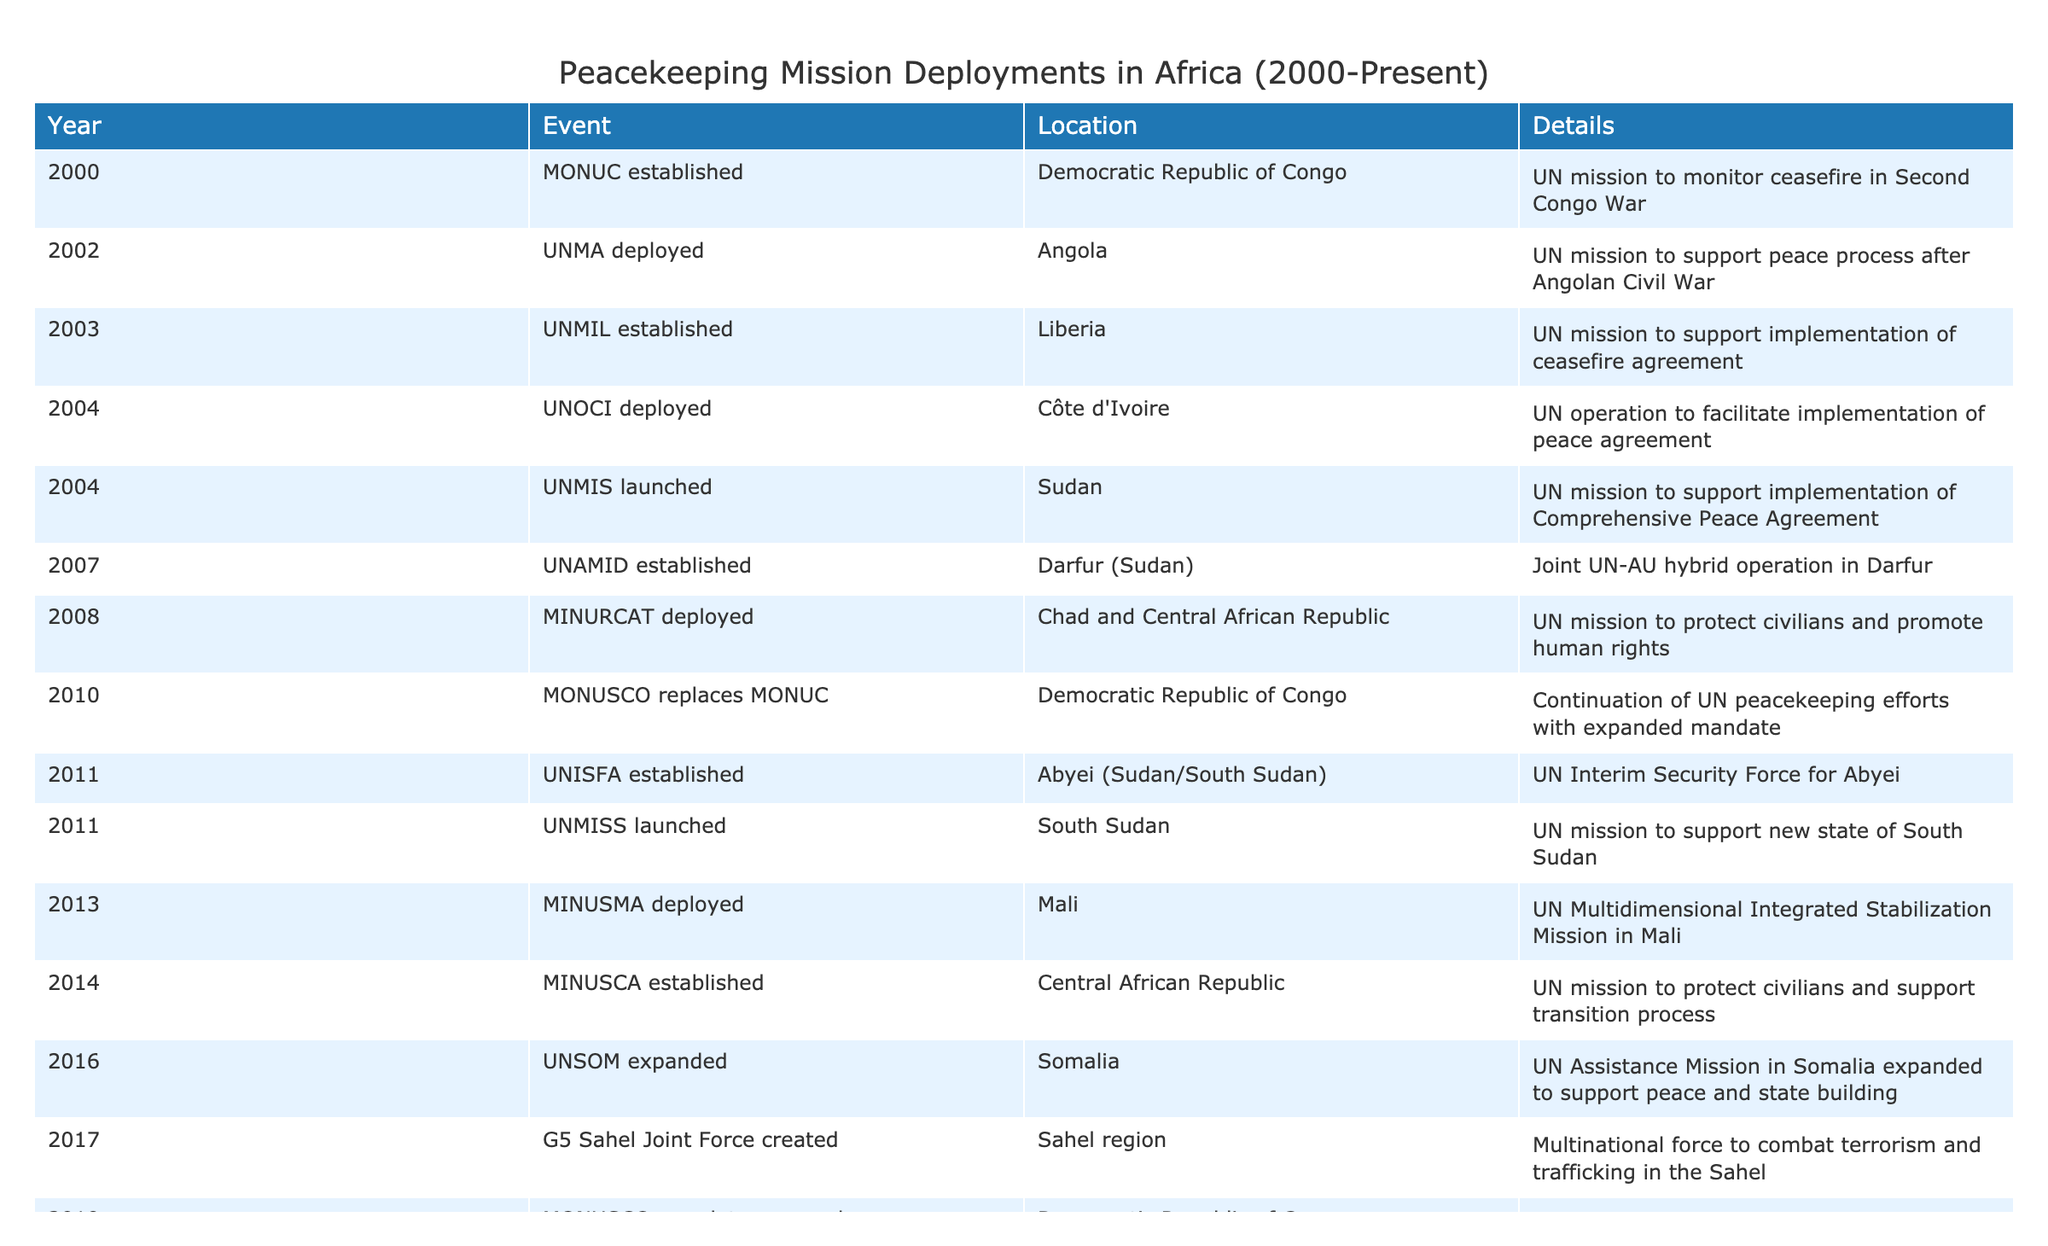What year was MONUC established? The table lists the establishment year for MONUC under the "Year" column, which shows that it was established in the year 2000.
Answer: 2000 Which mission was deployed in Angola? The table includes the event details for Angola, indicating that the UNMA mission was deployed there to support the peace process after the Angolan Civil War.
Answer: UNMA How many peacekeeping missions were established in 2011? By examining the table, we find that two missions were established in 2011: UNISFA for Abyei and UNMISS for South Sudan, leading to the total count of 2.
Answer: 2 Did Mali receive a peacekeeping mission in 2013? The table shows that MINUSMA was deployed in Mali in 2013, confirming that Mali did indeed receive a peacekeeping mission that year.
Answer: Yes What is the difference in years between the establishment of UNAMID and MINURCAT? UNAMID was established in 2007 and MINURCAT in 2008. To find the difference, we subtract: 2008 - 2007 = 1 year. Therefore, the difference is 1 year.
Answer: 1 year How many peacekeeping missions were initiated after 2015? We review the events from 2016 to 2022, noting that three missions were initiated during this period: UNSOM expanded (2016), G5 Sahel Joint Force (2017), and MINUSMA mandate strengthened (2022).
Answer: 3 Was there a peacekeeping mission focused on protecting civilians in the Central African Republic? The table indicates that MINUSCA was established in 2014 with the specific goal of protecting civilians and supporting the transition process. Therefore, the answer is yes.
Answer: Yes Which mission replaced AMISOM in Somalia, and what year did this occur? By checking the table, we see that AMISOM was transitioned to ATMIS in 2021, confirming the replacement mission and the corresponding year.
Answer: ATMIS, 2021 How many years elapsed between the establishment of UNOCI and the initiation of MINUSMA? UNOCI was deployed in 2004 and MINUSMA was deployed in 2013. To find the gap in years, we calculate: 2013 - 2004 = 9 years.
Answer: 9 years 